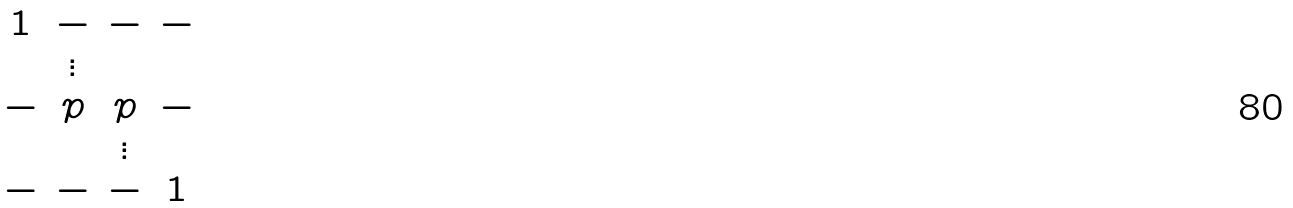Convert formula to latex. <formula><loc_0><loc_0><loc_500><loc_500>\begin{matrix} 1 & - & - & - \\ & \vdots & & \\ - & p & p & - \\ & & \vdots & \\ - & - & - & 1 \end{matrix}</formula> 